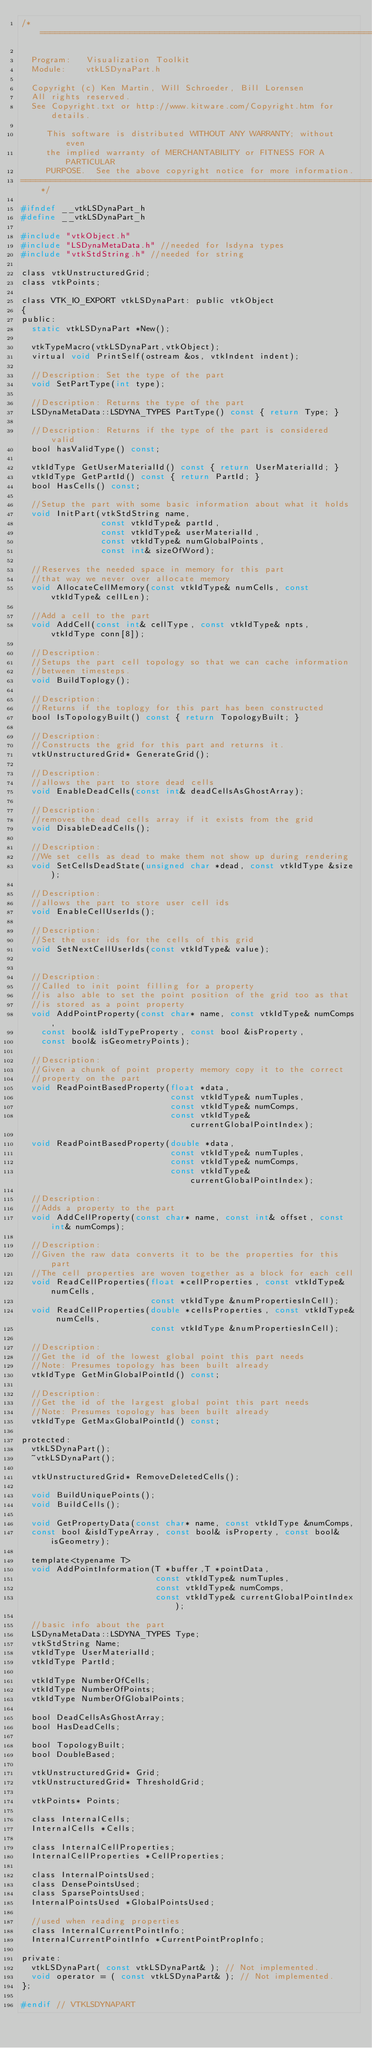Convert code to text. <code><loc_0><loc_0><loc_500><loc_500><_C_>/*=========================================================================

  Program:   Visualization Toolkit
  Module:    vtkLSDynaPart.h

  Copyright (c) Ken Martin, Will Schroeder, Bill Lorensen
  All rights reserved.
  See Copyright.txt or http://www.kitware.com/Copyright.htm for details.

     This software is distributed WITHOUT ANY WARRANTY; without even
     the implied warranty of MERCHANTABILITY or FITNESS FOR A PARTICULAR
     PURPOSE.  See the above copyright notice for more information.
=========================================================================*/

#ifndef __vtkLSDynaPart_h
#define __vtkLSDynaPart_h

#include "vtkObject.h"
#include "LSDynaMetaData.h" //needed for lsdyna types
#include "vtkStdString.h" //needed for string

class vtkUnstructuredGrid;
class vtkPoints;

class VTK_IO_EXPORT vtkLSDynaPart: public vtkObject
{
public:
  static vtkLSDynaPart *New();

  vtkTypeMacro(vtkLSDynaPart,vtkObject);
  virtual void PrintSelf(ostream &os, vtkIndent indent);

  //Description: Set the type of the part
  void SetPartType(int type);

  //Description: Returns the type of the part
  LSDynaMetaData::LSDYNA_TYPES PartType() const { return Type; }

  //Description: Returns if the type of the part is considered valid
  bool hasValidType() const;

  vtkIdType GetUserMaterialId() const { return UserMaterialId; }
  vtkIdType GetPartId() const { return PartId; }
  bool HasCells() const;

  //Setup the part with some basic information about what it holds
  void InitPart(vtkStdString name,
                const vtkIdType& partId,
                const vtkIdType& userMaterialId,
                const vtkIdType& numGlobalPoints,
                const int& sizeOfWord);

  //Reserves the needed space in memory for this part
  //that way we never over allocate memory
  void AllocateCellMemory(const vtkIdType& numCells, const vtkIdType& cellLen);

  //Add a cell to the part
  void AddCell(const int& cellType, const vtkIdType& npts, vtkIdType conn[8]);

  //Description:
  //Setups the part cell topology so that we can cache information
  //between timesteps.
  void BuildToplogy();

  //Description:
  //Returns if the toplogy for this part has been constructed
  bool IsTopologyBuilt() const { return TopologyBuilt; }

  //Description:
  //Constructs the grid for this part and returns it.
  vtkUnstructuredGrid* GenerateGrid();

  //Description:
  //allows the part to store dead cells
  void EnableDeadCells(const int& deadCellsAsGhostArray);

  //Description:
  //removes the dead cells array if it exists from the grid
  void DisableDeadCells();

  //Description:
  //We set cells as dead to make them not show up during rendering
  void SetCellsDeadState(unsigned char *dead, const vtkIdType &size);

  //Description:
  //allows the part to store user cell ids
  void EnableCellUserIds();

  //Description:
  //Set the user ids for the cells of this grid
  void SetNextCellUserIds(const vtkIdType& value);


  //Description:
  //Called to init point filling for a property
  //is also able to set the point position of the grid too as that
  //is stored as a point property
  void AddPointProperty(const char* name, const vtkIdType& numComps,
    const bool& isIdTypeProperty, const bool &isProperty,
    const bool& isGeometryPoints);

  //Description:
  //Given a chunk of point property memory copy it to the correct
  //property on the part
  void ReadPointBasedProperty(float *data,
                              const vtkIdType& numTuples,
                              const vtkIdType& numComps,
                              const vtkIdType& currentGlobalPointIndex);

  void ReadPointBasedProperty(double *data,
                              const vtkIdType& numTuples,
                              const vtkIdType& numComps,
                              const vtkIdType& currentGlobalPointIndex);

  //Description:
  //Adds a property to the part
  void AddCellProperty(const char* name, const int& offset, const int& numComps);

  //Description:
  //Given the raw data converts it to be the properties for this part
  //The cell properties are woven together as a block for each cell
  void ReadCellProperties(float *cellProperties, const vtkIdType& numCells,
                          const vtkIdType &numPropertiesInCell);
  void ReadCellProperties(double *cellsProperties, const vtkIdType& numCells,
                          const vtkIdType &numPropertiesInCell);

  //Description:
  //Get the id of the lowest global point this part needs
  //Note: Presumes topology has been built already
  vtkIdType GetMinGlobalPointId() const;

  //Description:
  //Get the id of the largest global point this part needs
  //Note: Presumes topology has been built already
  vtkIdType GetMaxGlobalPointId() const;

protected:
  vtkLSDynaPart();
  ~vtkLSDynaPart();

  vtkUnstructuredGrid* RemoveDeletedCells();

  void BuildUniquePoints();
  void BuildCells();

  void GetPropertyData(const char* name, const vtkIdType &numComps,
  const bool &isIdTypeArray, const bool& isProperty, const bool& isGeometry);

  template<typename T>
  void AddPointInformation(T *buffer,T *pointData,
                           const vtkIdType& numTuples,
                           const vtkIdType& numComps,
                           const vtkIdType& currentGlobalPointIndex);

  //basic info about the part
  LSDynaMetaData::LSDYNA_TYPES Type;
  vtkStdString Name;
  vtkIdType UserMaterialId;
  vtkIdType PartId;

  vtkIdType NumberOfCells;
  vtkIdType NumberOfPoints;
  vtkIdType NumberOfGlobalPoints;

  bool DeadCellsAsGhostArray;
  bool HasDeadCells;

  bool TopologyBuilt;
  bool DoubleBased;

  vtkUnstructuredGrid* Grid;
  vtkUnstructuredGrid* ThresholdGrid;

  vtkPoints* Points;

  class InternalCells;
  InternalCells *Cells;

  class InternalCellProperties;
  InternalCellProperties *CellProperties;

  class InternalPointsUsed;
  class DensePointsUsed;
  class SparsePointsUsed;
  InternalPointsUsed *GlobalPointsUsed;

  //used when reading properties
  class InternalCurrentPointInfo;
  InternalCurrentPointInfo *CurrentPointPropInfo;

private:
  vtkLSDynaPart( const vtkLSDynaPart& ); // Not implemented.
  void operator = ( const vtkLSDynaPart& ); // Not implemented.
};

#endif // VTKLSDYNAPART
</code> 